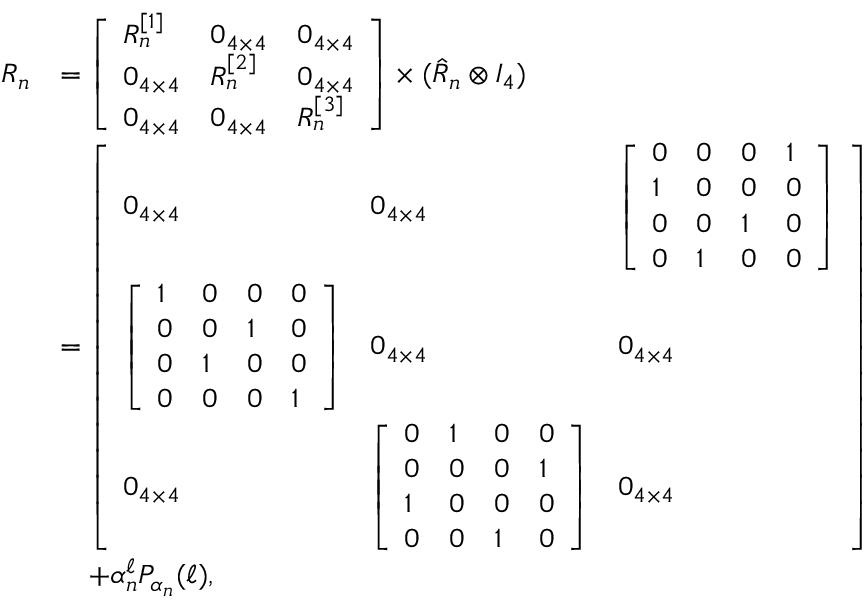Convert formula to latex. <formula><loc_0><loc_0><loc_500><loc_500>\begin{array} { r l } { R _ { n } } & { = \left [ \begin{array} { l l l } { R _ { n } ^ { [ 1 ] } } & { 0 _ { 4 \times 4 } } & { 0 _ { 4 \times 4 } } \\ { 0 _ { 4 \times 4 } } & { R _ { n } ^ { [ 2 ] } } & { 0 _ { 4 \times 4 } } \\ { 0 _ { 4 \times 4 } } & { 0 _ { 4 \times 4 } } & { R _ { n } ^ { [ 3 ] } } \end{array} \right ] \times ( \hat { R } _ { n } \otimes I _ { 4 } ) } \\ & { = \left [ \begin{array} { l l l } { 0 _ { 4 \times 4 } } & { 0 _ { 4 \times 4 } } & { \left [ \begin{array} { l l l l } { 0 } & { 0 } & { 0 } & { 1 } \\ { 1 } & { 0 } & { 0 } & { 0 } \\ { 0 } & { 0 } & { 1 } & { 0 } \\ { 0 } & { 1 } & { 0 } & { 0 } \end{array} \right ] } \\ { \left [ \begin{array} { l l l l } { 1 } & { 0 } & { 0 } & { 0 } \\ { 0 } & { 0 } & { 1 } & { 0 } \\ { 0 } & { 1 } & { 0 } & { 0 } \\ { 0 } & { 0 } & { 0 } & { 1 } \end{array} \right ] } & { 0 _ { 4 \times 4 } } & { 0 _ { 4 \times 4 } } \\ { 0 _ { 4 \times 4 } } & { \left [ \begin{array} { l l l l } { 0 } & { 1 } & { 0 } & { 0 } \\ { 0 } & { 0 } & { 0 } & { 1 } \\ { 1 } & { 0 } & { 0 } & { 0 } \\ { 0 } & { 0 } & { 1 } & { 0 } \end{array} \right ] } & { 0 _ { 4 \times 4 } } \end{array} \right ] } \\ & { \quad + \alpha _ { n } ^ { \ell } P _ { \alpha _ { n } } ( \ell ) , } \end{array}</formula> 